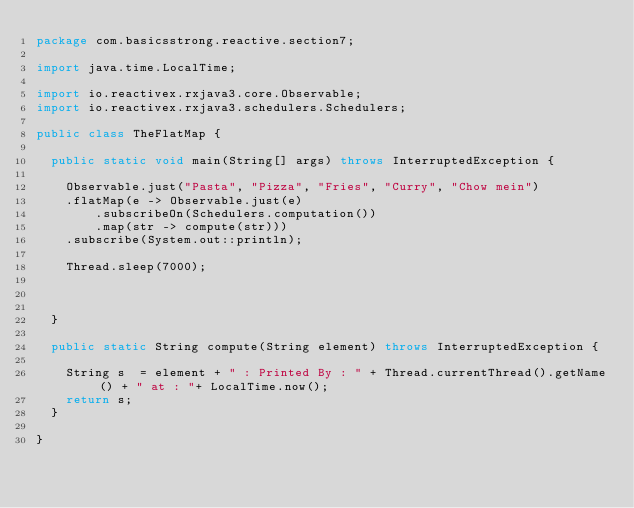Convert code to text. <code><loc_0><loc_0><loc_500><loc_500><_Java_>package com.basicsstrong.reactive.section7;

import java.time.LocalTime;

import io.reactivex.rxjava3.core.Observable;
import io.reactivex.rxjava3.schedulers.Schedulers;

public class TheFlatMap {

	public static void main(String[] args) throws InterruptedException {

		Observable.just("Pasta", "Pizza", "Fries", "Curry", "Chow mein")
		.flatMap(e -> Observable.just(e)
				.subscribeOn(Schedulers.computation())
				.map(str -> compute(str)))
		.subscribe(System.out::println);
		
		Thread.sleep(7000);
		
		
		
	}

	public static String compute(String element) throws InterruptedException {

		String s  = element + " : Printed By : " + Thread.currentThread().getName() + " at : "+ LocalTime.now();
		return s;
	}

}
</code> 